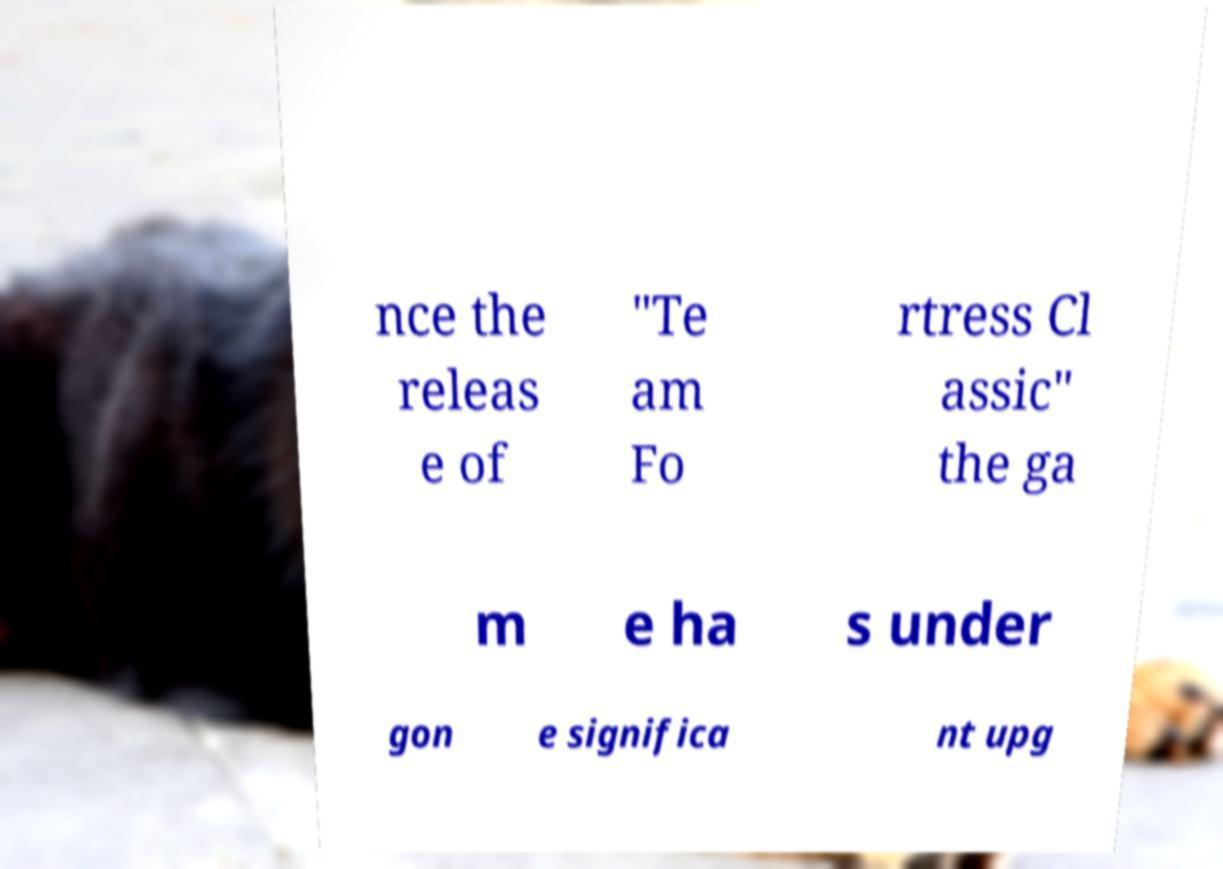Could you assist in decoding the text presented in this image and type it out clearly? nce the releas e of "Te am Fo rtress Cl assic" the ga m e ha s under gon e significa nt upg 